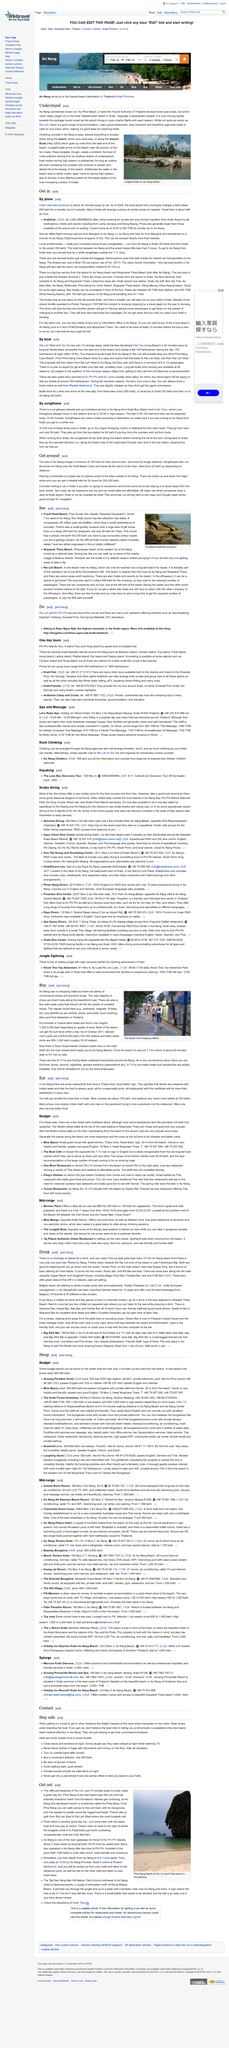Specify some key components in this picture. In Ao Nang, almost everything is located either along the beach or along Airport Road. The photograph was taken at Ao Nang Beach. The Tourist Authority of Thailand has designated the name "Ao Phra Nang" for Ao Nang some years ago. 